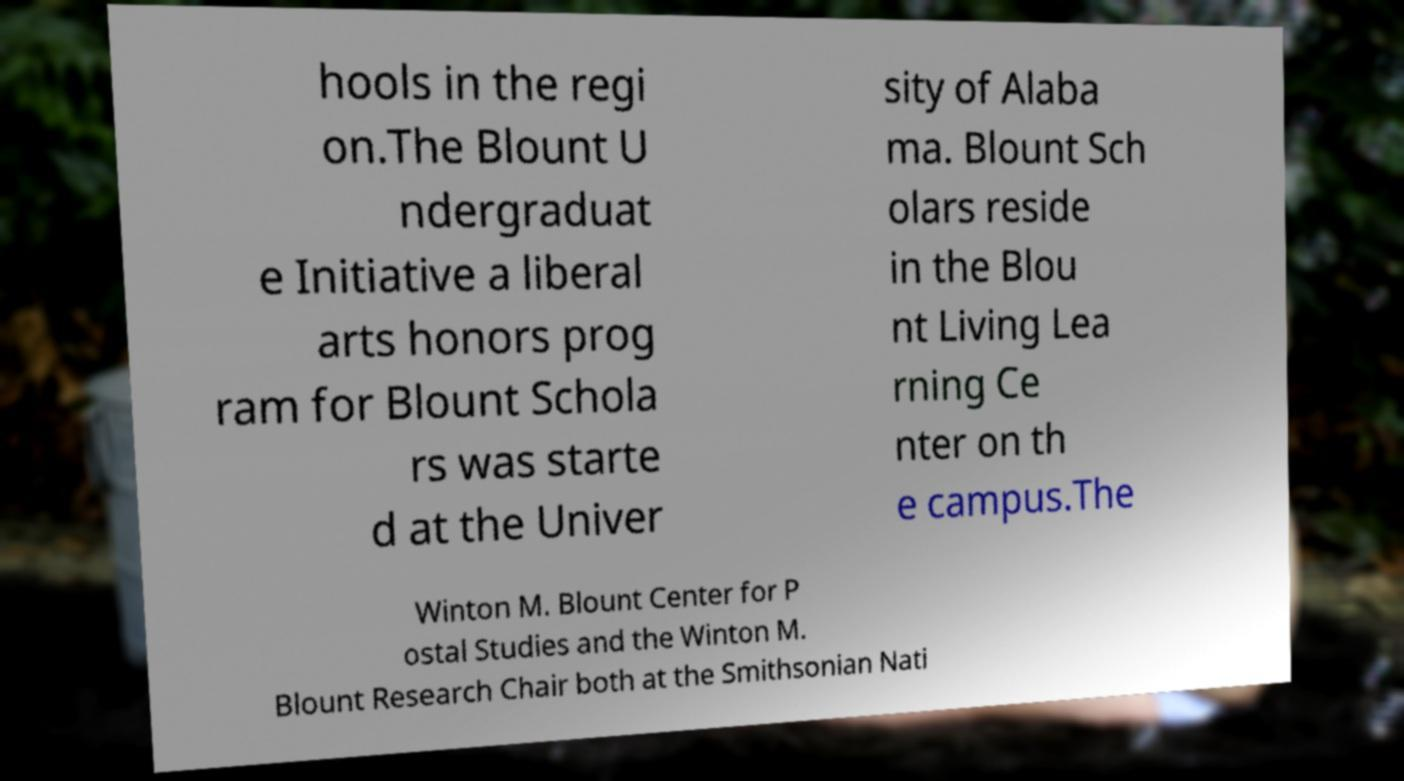There's text embedded in this image that I need extracted. Can you transcribe it verbatim? hools in the regi on.The Blount U ndergraduat e Initiative a liberal arts honors prog ram for Blount Schola rs was starte d at the Univer sity of Alaba ma. Blount Sch olars reside in the Blou nt Living Lea rning Ce nter on th e campus.The Winton M. Blount Center for P ostal Studies and the Winton M. Blount Research Chair both at the Smithsonian Nati 